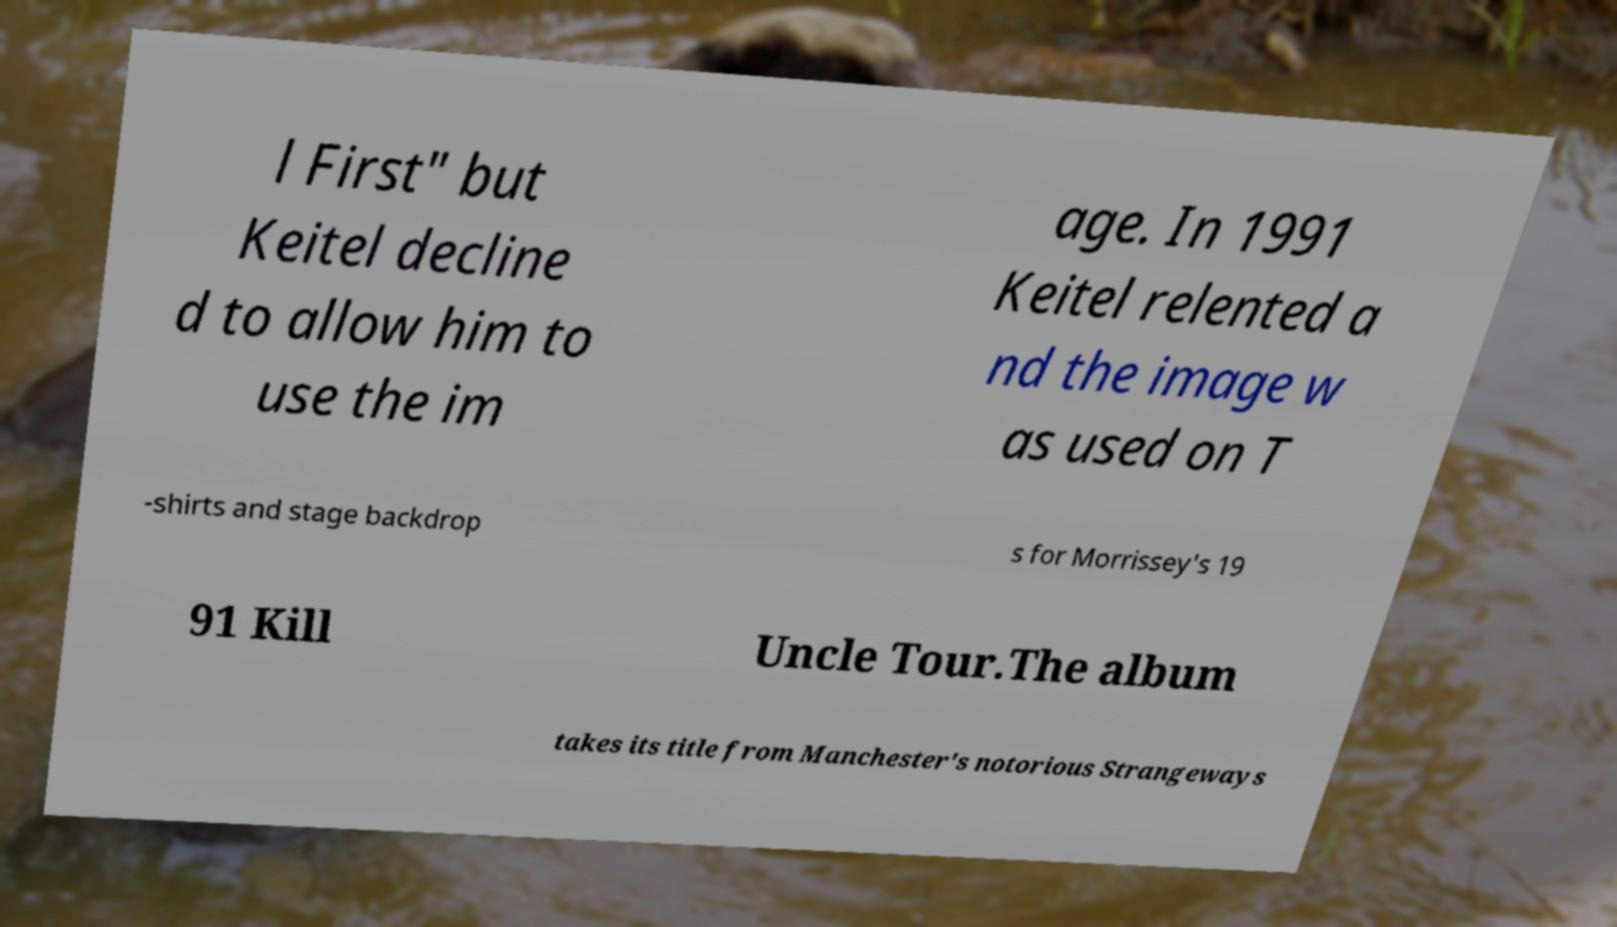What messages or text are displayed in this image? I need them in a readable, typed format. l First" but Keitel decline d to allow him to use the im age. In 1991 Keitel relented a nd the image w as used on T -shirts and stage backdrop s for Morrissey's 19 91 Kill Uncle Tour.The album takes its title from Manchester's notorious Strangeways 